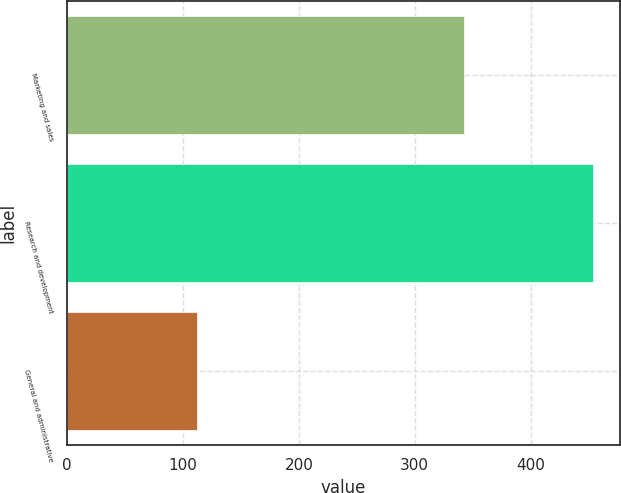Convert chart. <chart><loc_0><loc_0><loc_500><loc_500><bar_chart><fcel>Marketing and sales<fcel>Research and development<fcel>General and administrative<nl><fcel>342.3<fcel>454.1<fcel>112.1<nl></chart> 